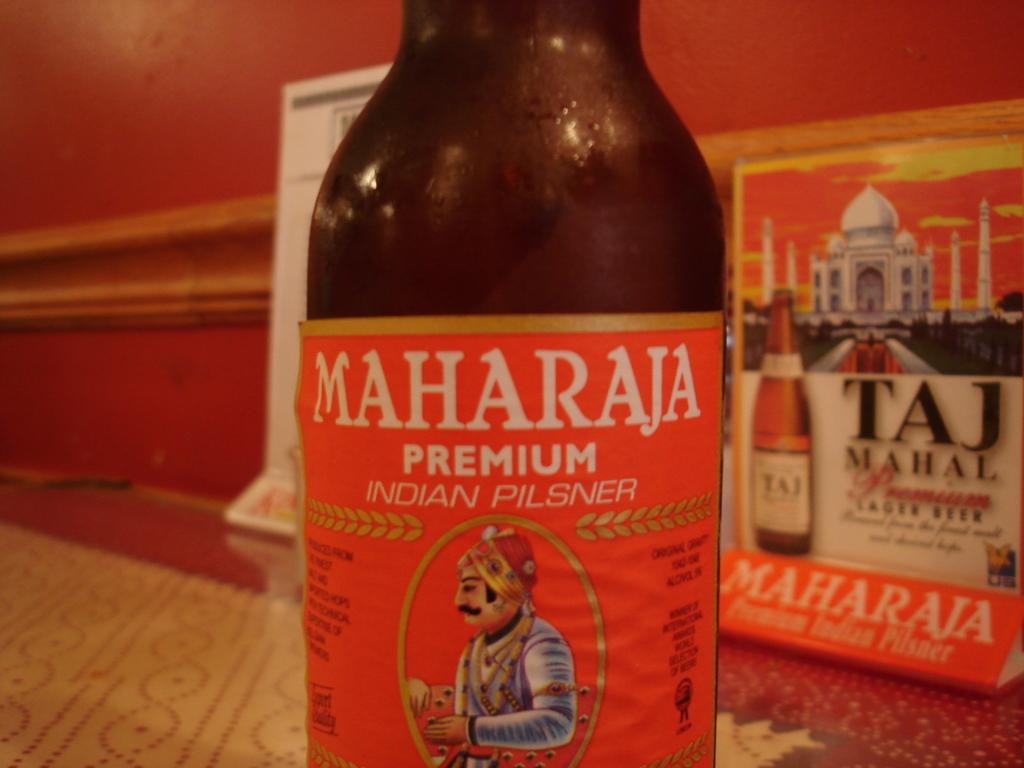What brand is this?
Your answer should be compact. Maharaja. 